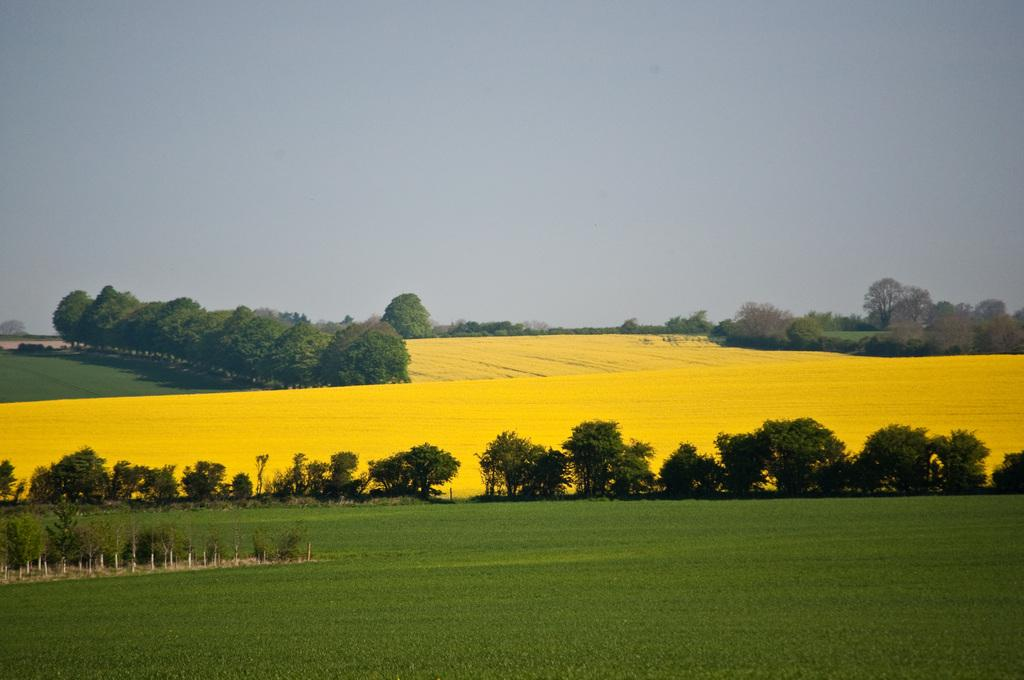What type of vegetation is present on the ground in the image? There is grass on the ground in the image. What color are the trees in the image? The trees in the image are green. What is the condition of the sky in the image? The sky is cloudy in the image. What is the title of the book that is lying on the grass in the image? There is no book present in the image; it only features grass, green trees, and a cloudy sky. What type of thread is being used to sew the leaves of the trees in the image? There is no thread or sewing involved in the image; the trees are naturally connected to their branches and leaves. 